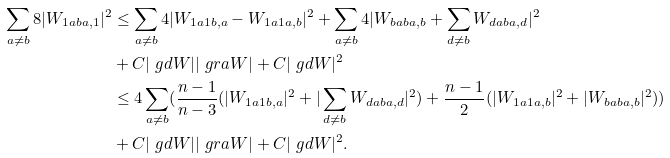Convert formula to latex. <formula><loc_0><loc_0><loc_500><loc_500>\sum _ { a \neq b } 8 | W _ { 1 a b a , 1 } | ^ { 2 } & \leq \sum _ { a \neq b } 4 | W _ { 1 a 1 b , a } - W _ { 1 a 1 a , b } | ^ { 2 } + \sum _ { a \neq b } 4 | W _ { b a b a , b } + \sum _ { d \neq b } W _ { d a b a , d } | ^ { 2 } \\ & + C | \ g d W | | \ g r a W | + C | \ g d W | ^ { 2 } \\ & \leq 4 \sum _ { a \neq b } ( \frac { n - 1 } { n - 3 } ( | W _ { 1 a 1 b , a } | ^ { 2 } + | \sum _ { d \neq b } W _ { d a b a , d } | ^ { 2 } ) + \frac { n - 1 } { 2 } ( | W _ { 1 a 1 a , b } | ^ { 2 } + | W _ { b a b a , b } | ^ { 2 } ) ) \\ & + C | \ g d W | | \ g r a W | + C | \ g d W | ^ { 2 } .</formula> 